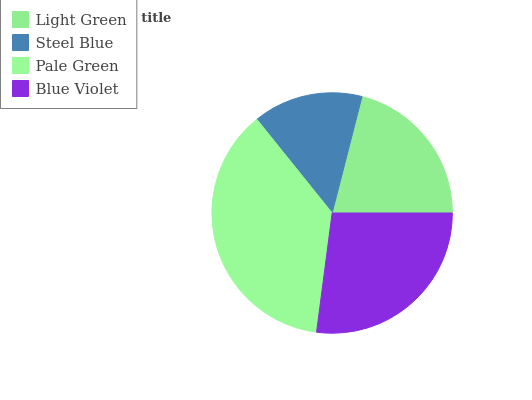Is Steel Blue the minimum?
Answer yes or no. Yes. Is Pale Green the maximum?
Answer yes or no. Yes. Is Pale Green the minimum?
Answer yes or no. No. Is Steel Blue the maximum?
Answer yes or no. No. Is Pale Green greater than Steel Blue?
Answer yes or no. Yes. Is Steel Blue less than Pale Green?
Answer yes or no. Yes. Is Steel Blue greater than Pale Green?
Answer yes or no. No. Is Pale Green less than Steel Blue?
Answer yes or no. No. Is Blue Violet the high median?
Answer yes or no. Yes. Is Light Green the low median?
Answer yes or no. Yes. Is Pale Green the high median?
Answer yes or no. No. Is Steel Blue the low median?
Answer yes or no. No. 